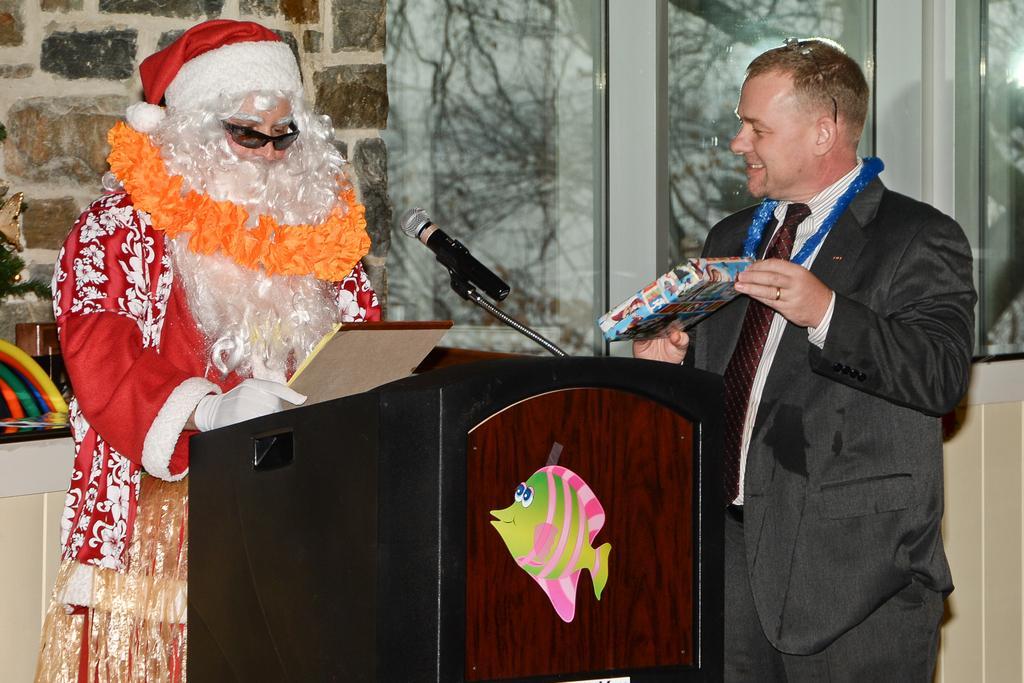Can you describe this image briefly? On the left side a person is in the shape of a Christmas grand father and speaking in the microphone, on the right side a man is standing and smiling, he wore black color coat, trouser and red color tie. Behind him there are window glasses. 